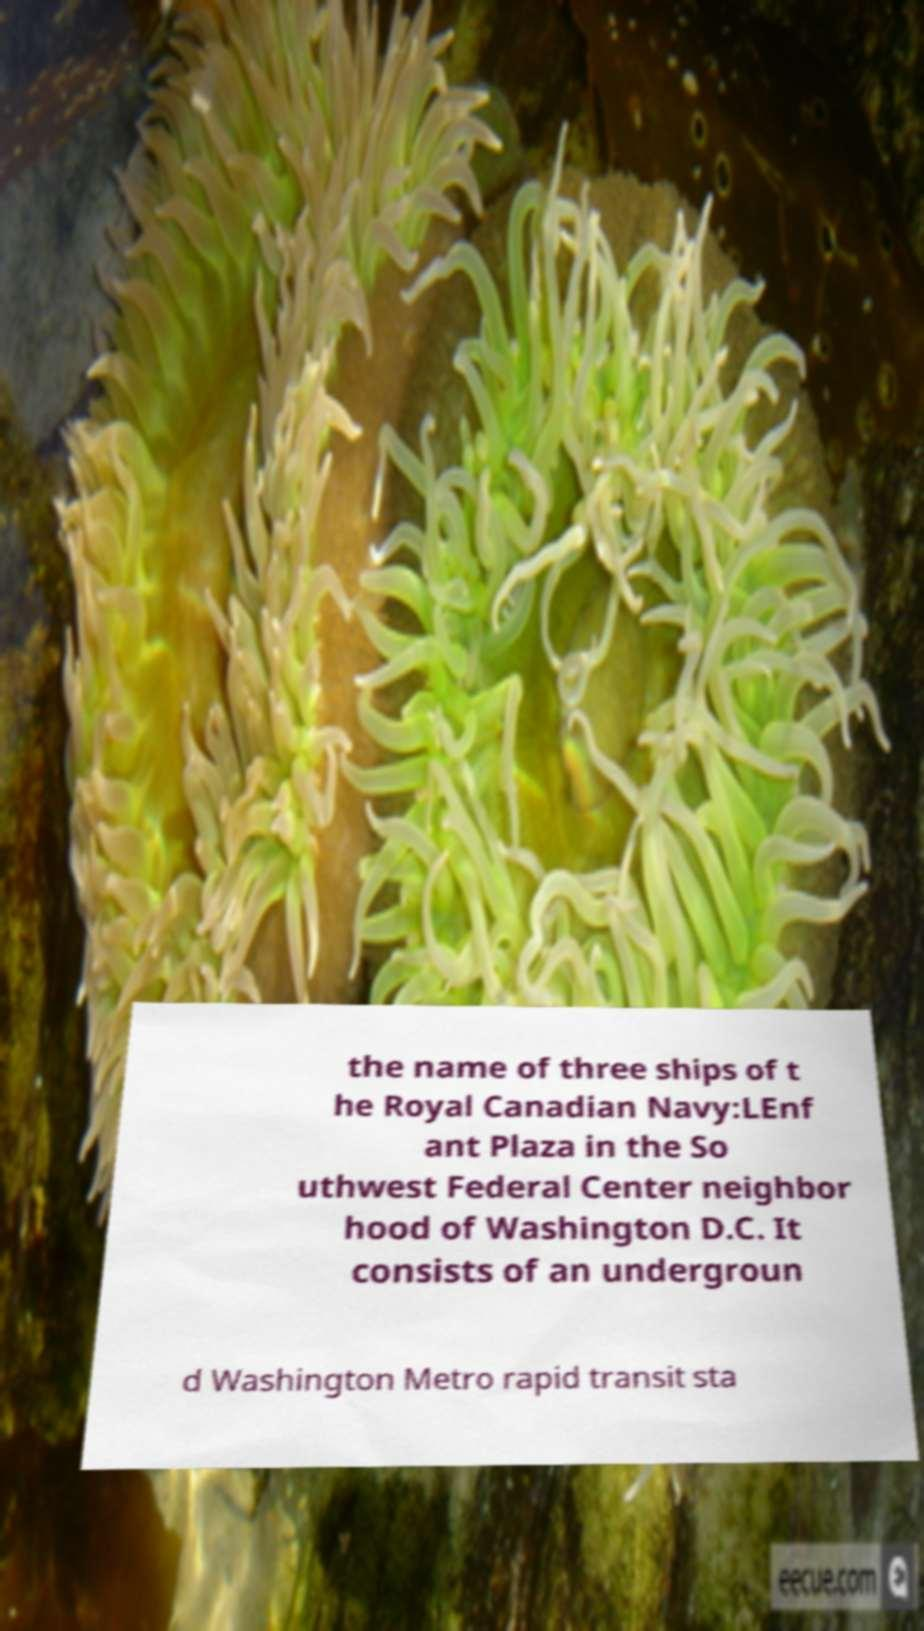Can you read and provide the text displayed in the image?This photo seems to have some interesting text. Can you extract and type it out for me? the name of three ships of t he Royal Canadian Navy:LEnf ant Plaza in the So uthwest Federal Center neighbor hood of Washington D.C. It consists of an undergroun d Washington Metro rapid transit sta 